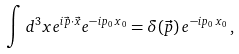Convert formula to latex. <formula><loc_0><loc_0><loc_500><loc_500>\int d ^ { 3 } x e ^ { i \vec { p } \cdot \vec { x } } e ^ { - i p _ { 0 } \, { x } _ { 0 } } = \delta ( \vec { p } ) \, e ^ { - i p _ { 0 } \, { x } _ { 0 } } \, ,</formula> 